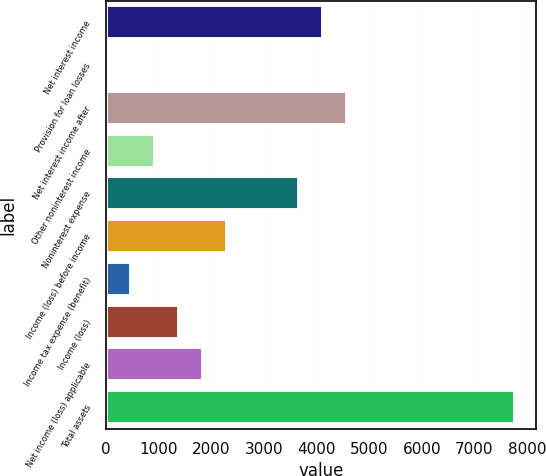<chart> <loc_0><loc_0><loc_500><loc_500><bar_chart><fcel>Net interest income<fcel>Provision for loan losses<fcel>Net interest income after<fcel>Other noninterest income<fcel>Noninterest expense<fcel>Income (loss) before income<fcel>Income tax expense (benefit)<fcel>Income (loss)<fcel>Net income (loss) applicable<fcel>Total assets<nl><fcel>4122.6<fcel>15<fcel>4579<fcel>927.8<fcel>3666.2<fcel>2297<fcel>471.4<fcel>1384.2<fcel>1840.6<fcel>7773.8<nl></chart> 